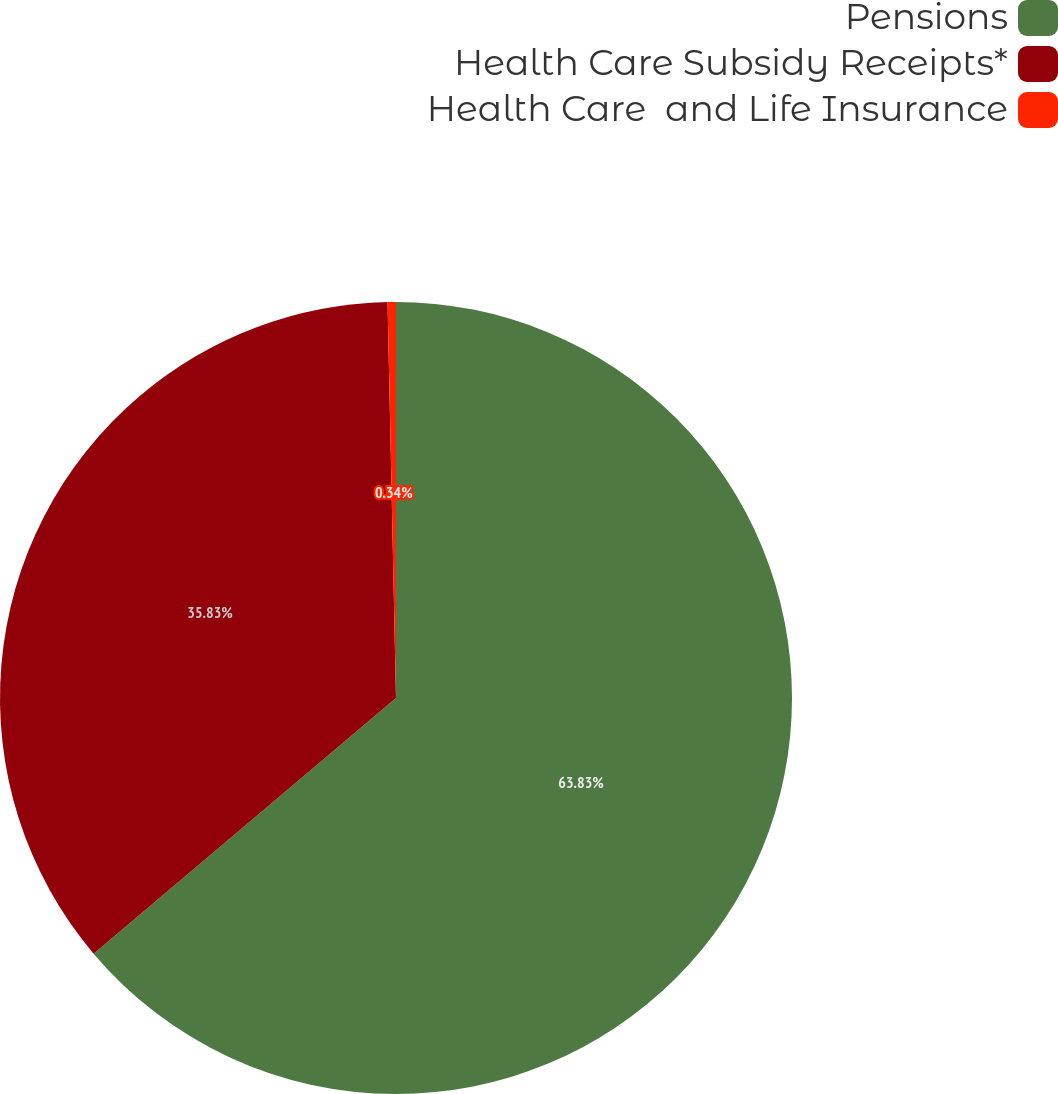Convert chart to OTSL. <chart><loc_0><loc_0><loc_500><loc_500><pie_chart><fcel>Pensions<fcel>Health Care Subsidy Receipts*<fcel>Health Care  and Life Insurance<nl><fcel>63.83%<fcel>35.83%<fcel>0.34%<nl></chart> 